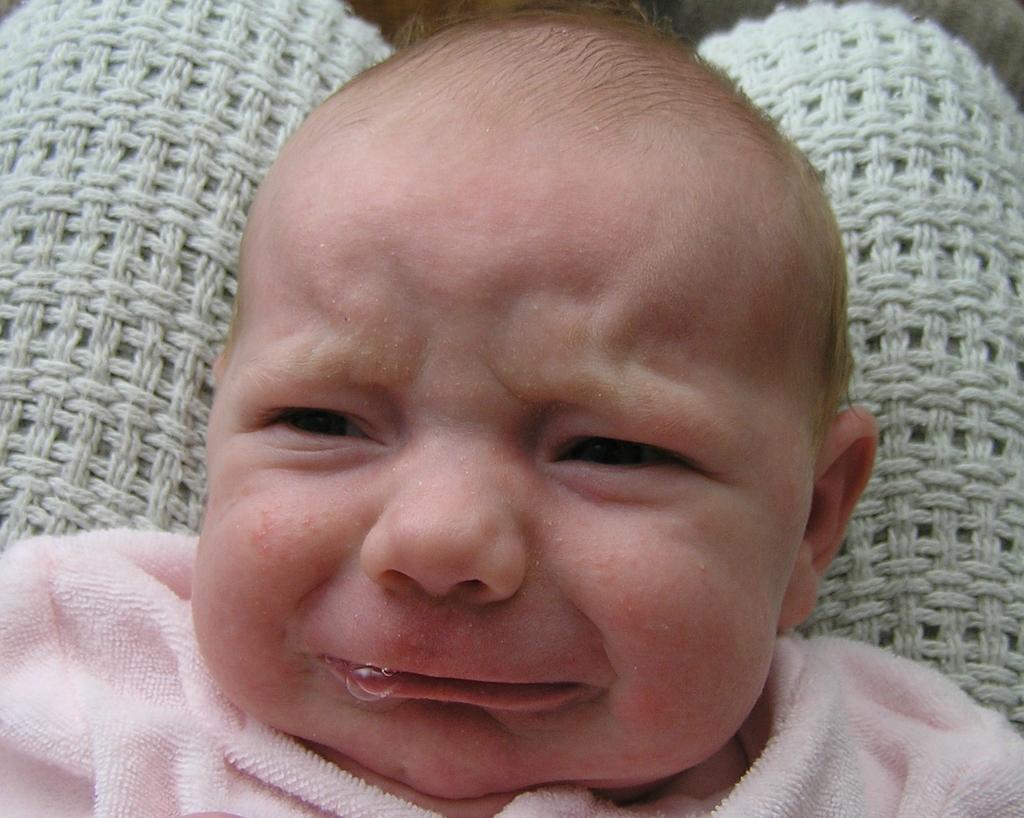Could you give a brief overview of what you see in this image? In the center of the image we can see one woolen cloth. On the woolen cloth, we can see one baby is lying and we can see the baby is crying. And we can see one pink towel on the baby. In the background, we can see it is blurred. 